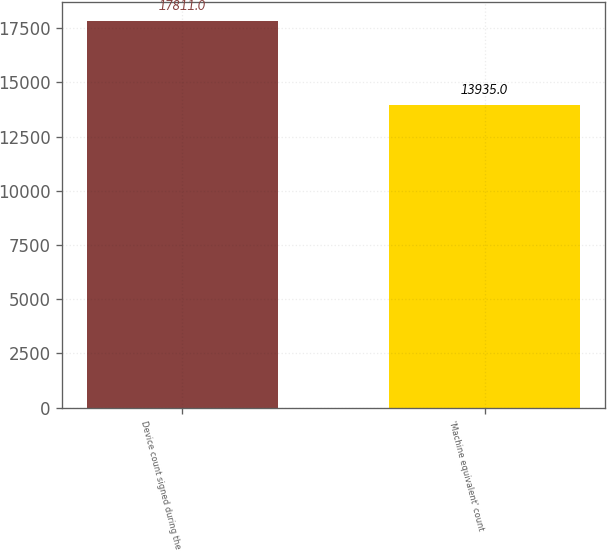Convert chart to OTSL. <chart><loc_0><loc_0><loc_500><loc_500><bar_chart><fcel>Device count signed during the<fcel>'Machine equivalent' count<nl><fcel>17811<fcel>13935<nl></chart> 